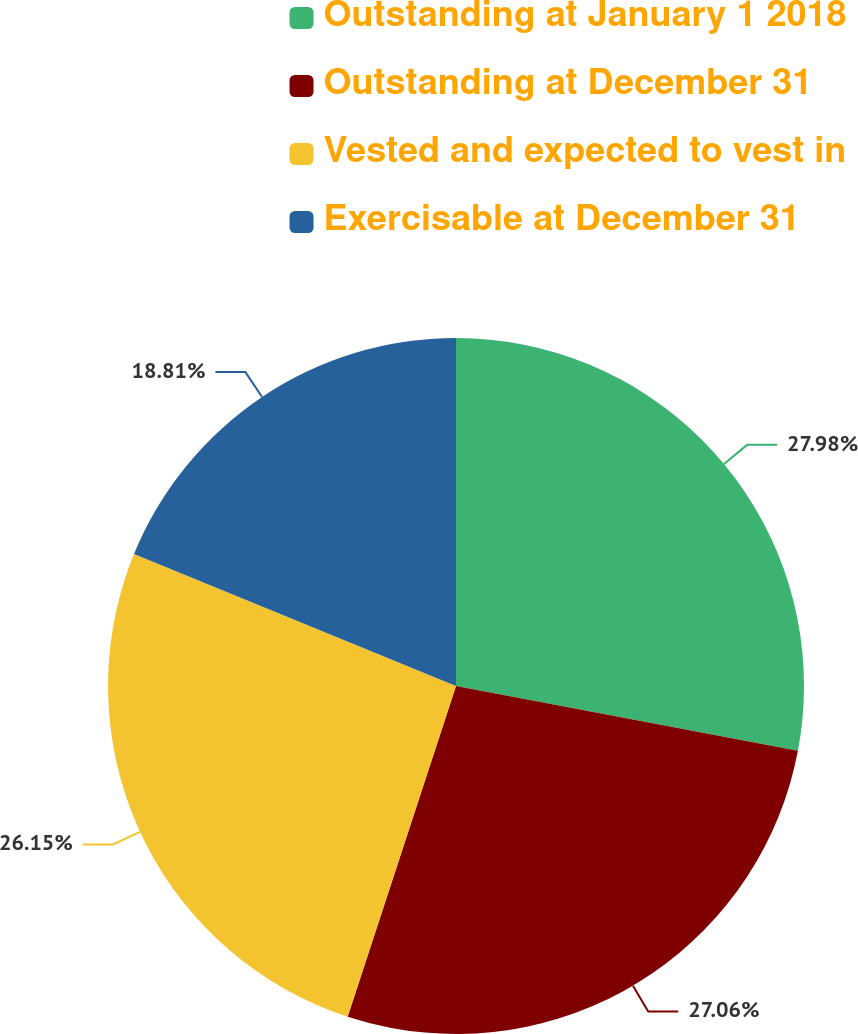Convert chart to OTSL. <chart><loc_0><loc_0><loc_500><loc_500><pie_chart><fcel>Outstanding at January 1 2018<fcel>Outstanding at December 31<fcel>Vested and expected to vest in<fcel>Exercisable at December 31<nl><fcel>27.98%<fcel>27.06%<fcel>26.15%<fcel>18.81%<nl></chart> 